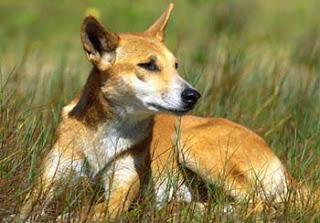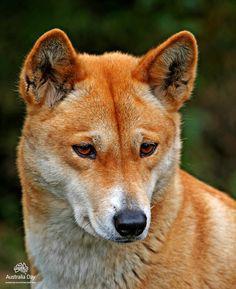The first image is the image on the left, the second image is the image on the right. Evaluate the accuracy of this statement regarding the images: "Some of the dingoes are howling.". Is it true? Answer yes or no. No. The first image is the image on the left, the second image is the image on the right. Analyze the images presented: Is the assertion "An image contains at least two canines." valid? Answer yes or no. No. 